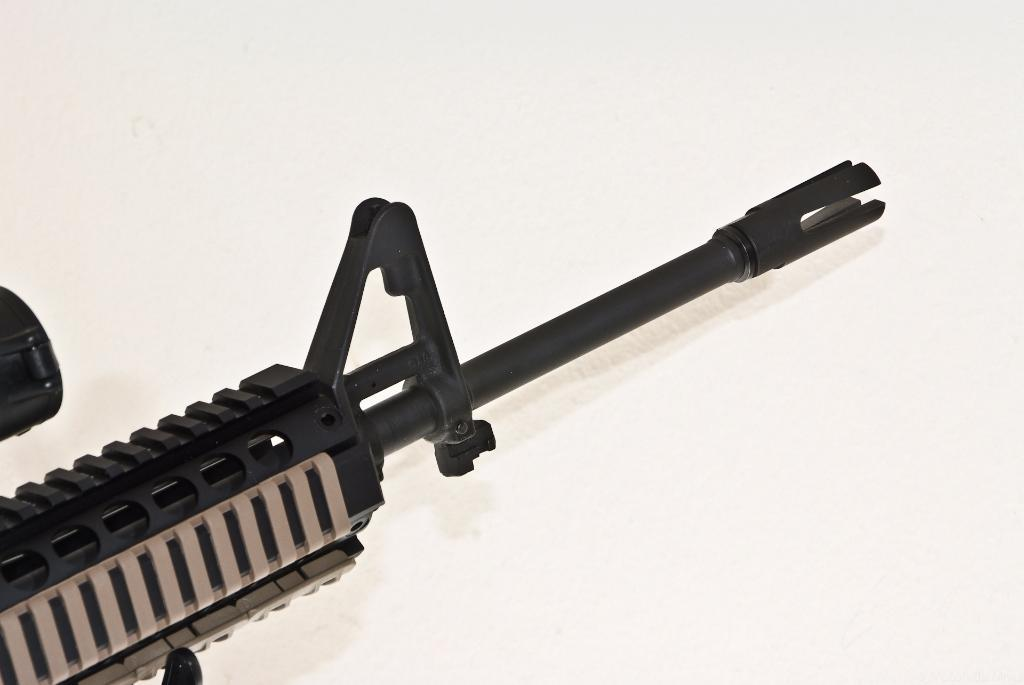What type of object is depicted in the image? There is a weapon in the image. How many cats are playing baseball with mint leaves in the image? There are no cats, baseball, or mint leaves present in the image; it features a weapon. 